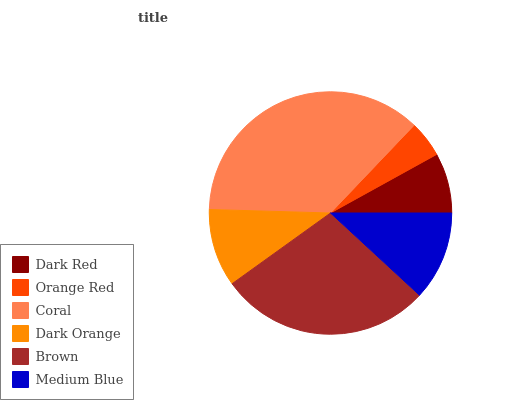Is Orange Red the minimum?
Answer yes or no. Yes. Is Coral the maximum?
Answer yes or no. Yes. Is Coral the minimum?
Answer yes or no. No. Is Orange Red the maximum?
Answer yes or no. No. Is Coral greater than Orange Red?
Answer yes or no. Yes. Is Orange Red less than Coral?
Answer yes or no. Yes. Is Orange Red greater than Coral?
Answer yes or no. No. Is Coral less than Orange Red?
Answer yes or no. No. Is Medium Blue the high median?
Answer yes or no. Yes. Is Dark Orange the low median?
Answer yes or no. Yes. Is Orange Red the high median?
Answer yes or no. No. Is Medium Blue the low median?
Answer yes or no. No. 